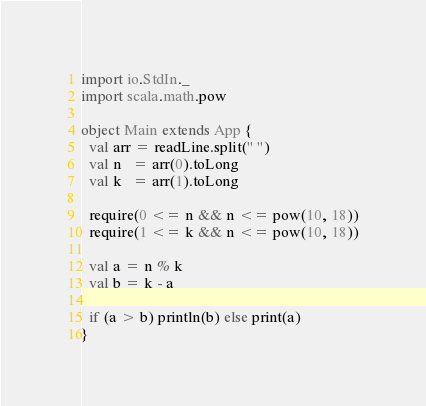Convert code to text. <code><loc_0><loc_0><loc_500><loc_500><_Scala_>import io.StdIn._
import scala.math.pow
 
object Main extends App {
  val arr = readLine.split(" ")
  val n   = arr(0).toLong
  val k   = arr(1).toLong
 
  require(0 <= n && n <= pow(10, 18))
  require(1 <= k && n <= pow(10, 18))
 
  val a = n % k
  val b = k - a
 
  if (a > b) println(b) else print(a)
}</code> 